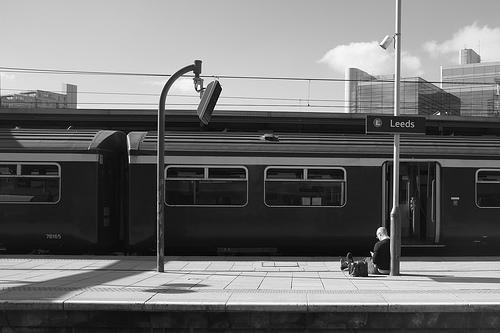How many people can be seen?
Give a very brief answer. 1. 